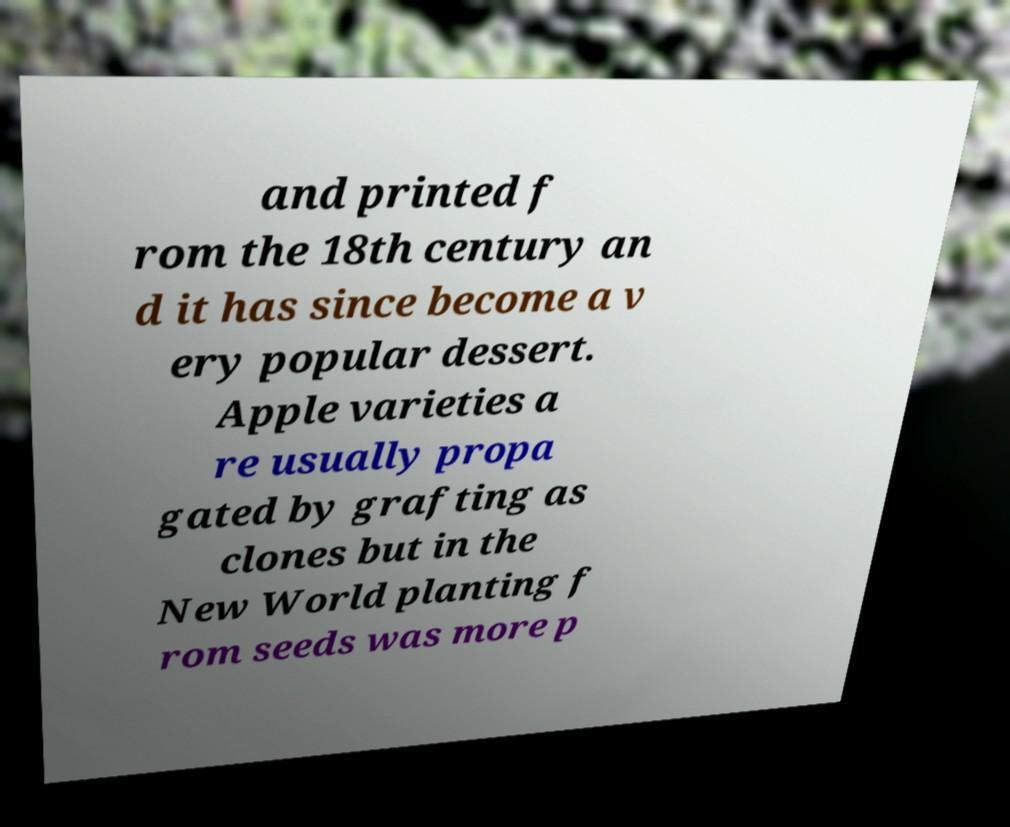Could you extract and type out the text from this image? and printed f rom the 18th century an d it has since become a v ery popular dessert. Apple varieties a re usually propa gated by grafting as clones but in the New World planting f rom seeds was more p 